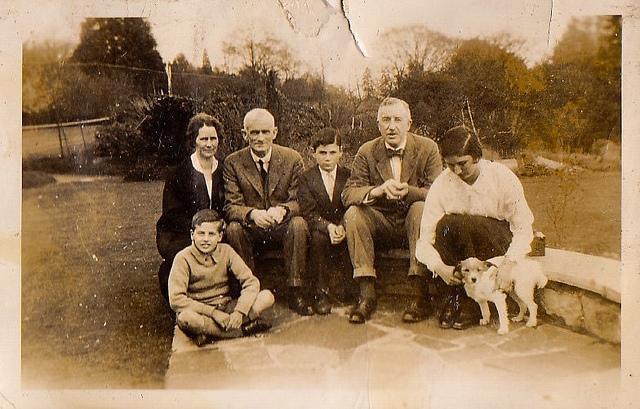How many people are wearing ties?
Give a very brief answer. 2. How many people are visible?
Give a very brief answer. 6. How many sinks are in this picture?
Give a very brief answer. 0. 